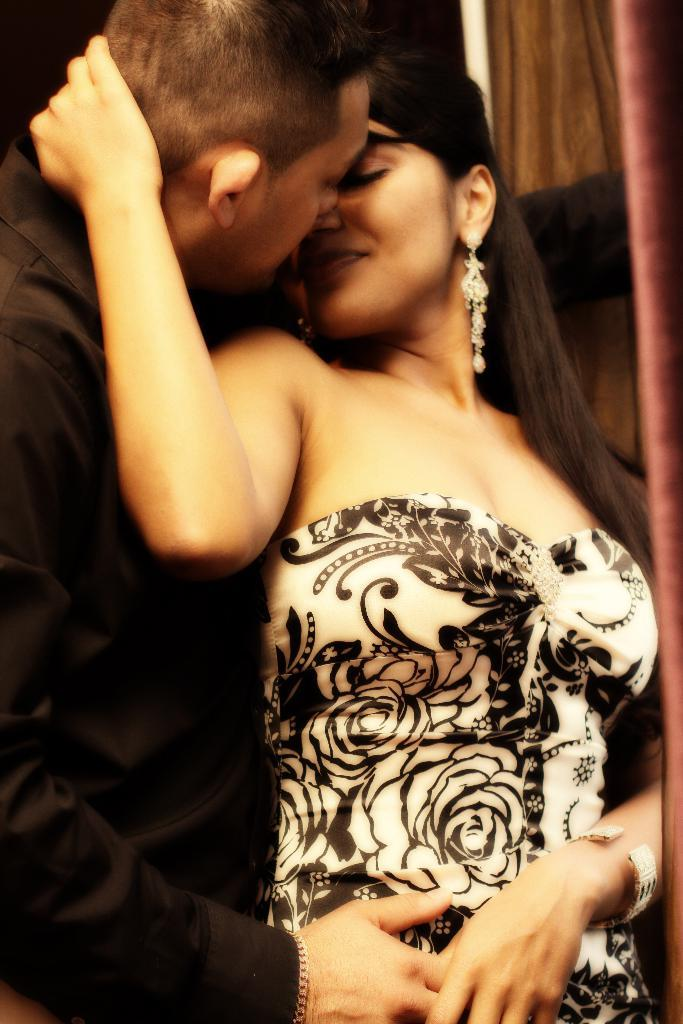How many people are present in the image? There are two persons in the image. What can be observed about the attire of the persons in the image? Both persons are wearing clothes. Are there any horses present in the image? No, there are no horses visible in the image. What type of basin can be seen in the image? There is no basin present in the image. 